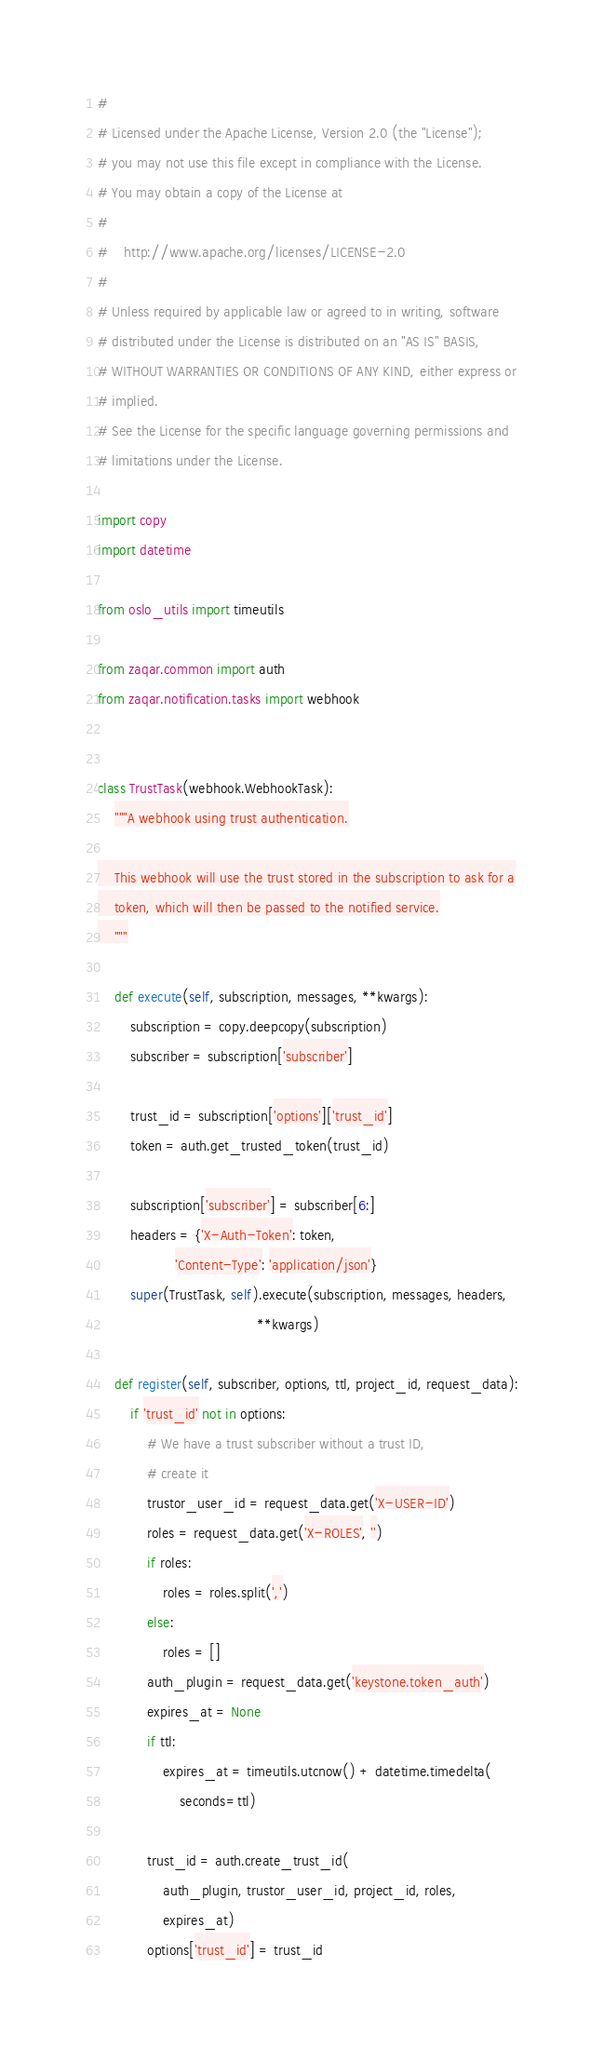<code> <loc_0><loc_0><loc_500><loc_500><_Python_>#
# Licensed under the Apache License, Version 2.0 (the "License");
# you may not use this file except in compliance with the License.
# You may obtain a copy of the License at
#
#    http://www.apache.org/licenses/LICENSE-2.0
#
# Unless required by applicable law or agreed to in writing, software
# distributed under the License is distributed on an "AS IS" BASIS,
# WITHOUT WARRANTIES OR CONDITIONS OF ANY KIND, either express or
# implied.
# See the License for the specific language governing permissions and
# limitations under the License.

import copy
import datetime

from oslo_utils import timeutils

from zaqar.common import auth
from zaqar.notification.tasks import webhook


class TrustTask(webhook.WebhookTask):
    """A webhook using trust authentication.

    This webhook will use the trust stored in the subscription to ask for a
    token, which will then be passed to the notified service.
    """

    def execute(self, subscription, messages, **kwargs):
        subscription = copy.deepcopy(subscription)
        subscriber = subscription['subscriber']

        trust_id = subscription['options']['trust_id']
        token = auth.get_trusted_token(trust_id)

        subscription['subscriber'] = subscriber[6:]
        headers = {'X-Auth-Token': token,
                   'Content-Type': 'application/json'}
        super(TrustTask, self).execute(subscription, messages, headers,
                                       **kwargs)

    def register(self, subscriber, options, ttl, project_id, request_data):
        if 'trust_id' not in options:
            # We have a trust subscriber without a trust ID,
            # create it
            trustor_user_id = request_data.get('X-USER-ID')
            roles = request_data.get('X-ROLES', '')
            if roles:
                roles = roles.split(',')
            else:
                roles = []
            auth_plugin = request_data.get('keystone.token_auth')
            expires_at = None
            if ttl:
                expires_at = timeutils.utcnow() + datetime.timedelta(
                    seconds=ttl)

            trust_id = auth.create_trust_id(
                auth_plugin, trustor_user_id, project_id, roles,
                expires_at)
            options['trust_id'] = trust_id
</code> 